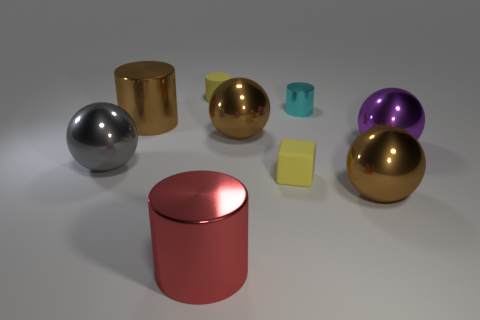There is a cylinder that is right of the yellow cylinder; is its size the same as the gray metal thing?
Your answer should be compact. No. What size is the cyan thing that is the same shape as the large red metal thing?
Your answer should be very brief. Small. What material is the yellow block that is the same size as the cyan metal cylinder?
Offer a very short reply. Rubber. There is a big purple thing that is the same shape as the large gray metal thing; what material is it?
Provide a short and direct response. Metal. What number of other objects are there of the same size as the cyan metal thing?
Offer a terse response. 2. There is a rubber cylinder that is the same color as the matte block; what size is it?
Your response must be concise. Small. What number of rubber objects have the same color as the rubber cube?
Provide a short and direct response. 1. What shape is the gray thing?
Make the answer very short. Sphere. There is a big metallic thing that is both to the left of the big red cylinder and in front of the large brown metal cylinder; what is its color?
Keep it short and to the point. Gray. What is the material of the large gray object?
Make the answer very short. Metal. 